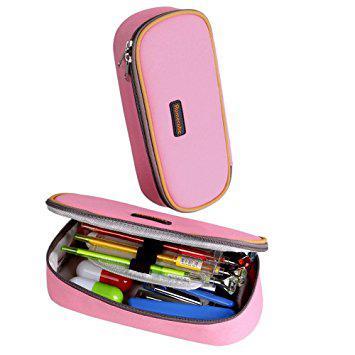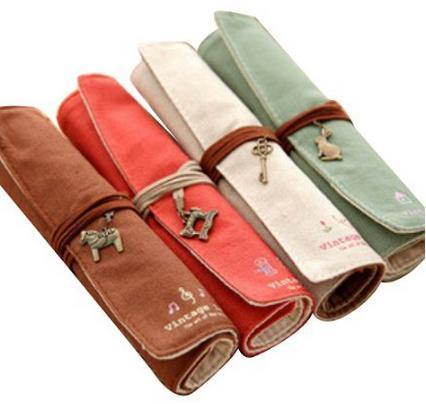The first image is the image on the left, the second image is the image on the right. Evaluate the accuracy of this statement regarding the images: "Right and left images show the same number of pencil cases displayed in the same directional position.". Is it true? Answer yes or no. No. The first image is the image on the left, the second image is the image on the right. Given the left and right images, does the statement "Four different variations of a pencil case, all of them closed, are depicted in one image." hold true? Answer yes or no. Yes. 